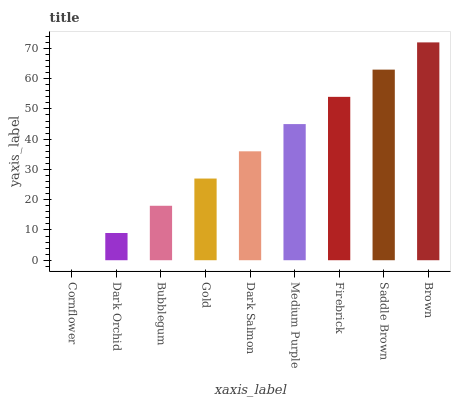Is Cornflower the minimum?
Answer yes or no. Yes. Is Brown the maximum?
Answer yes or no. Yes. Is Dark Orchid the minimum?
Answer yes or no. No. Is Dark Orchid the maximum?
Answer yes or no. No. Is Dark Orchid greater than Cornflower?
Answer yes or no. Yes. Is Cornflower less than Dark Orchid?
Answer yes or no. Yes. Is Cornflower greater than Dark Orchid?
Answer yes or no. No. Is Dark Orchid less than Cornflower?
Answer yes or no. No. Is Dark Salmon the high median?
Answer yes or no. Yes. Is Dark Salmon the low median?
Answer yes or no. Yes. Is Saddle Brown the high median?
Answer yes or no. No. Is Firebrick the low median?
Answer yes or no. No. 